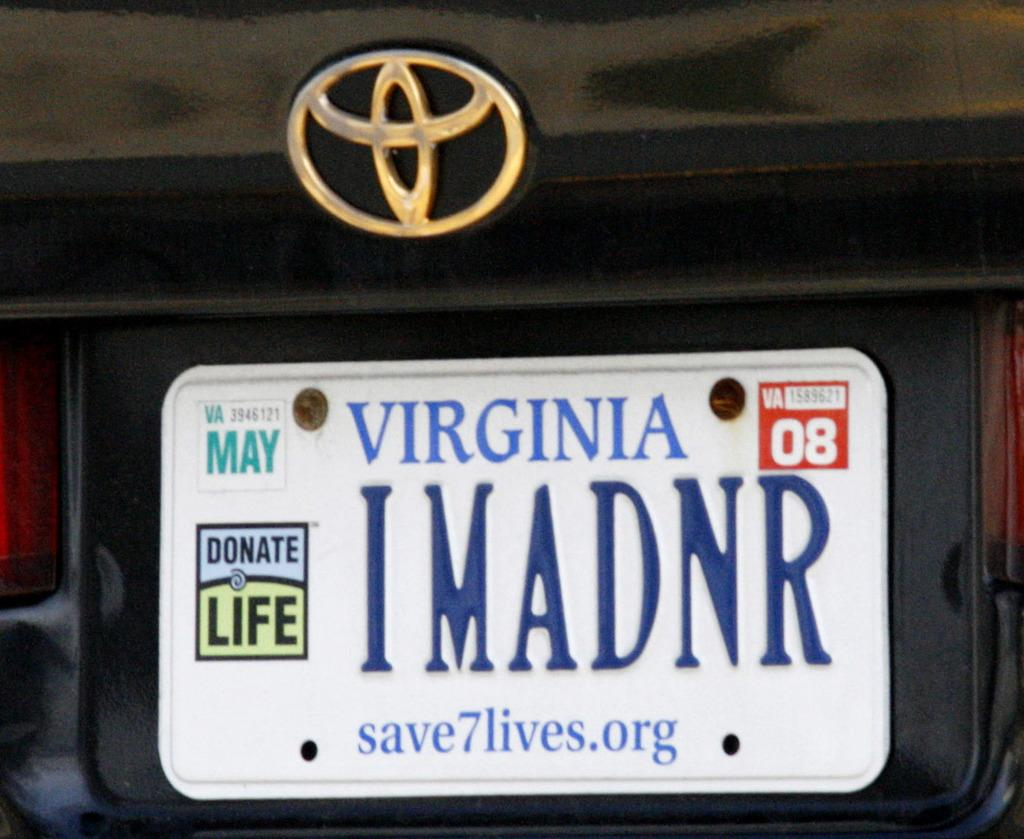<image>
Relay a brief, clear account of the picture shown. White Virginia license plate which says IMADNR on it. 